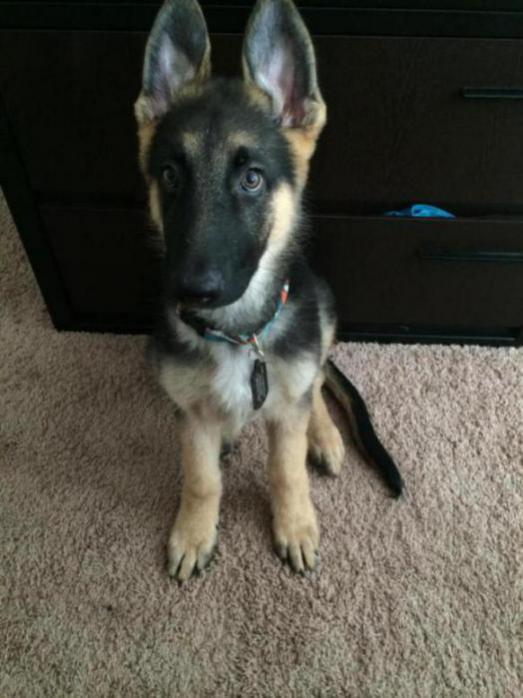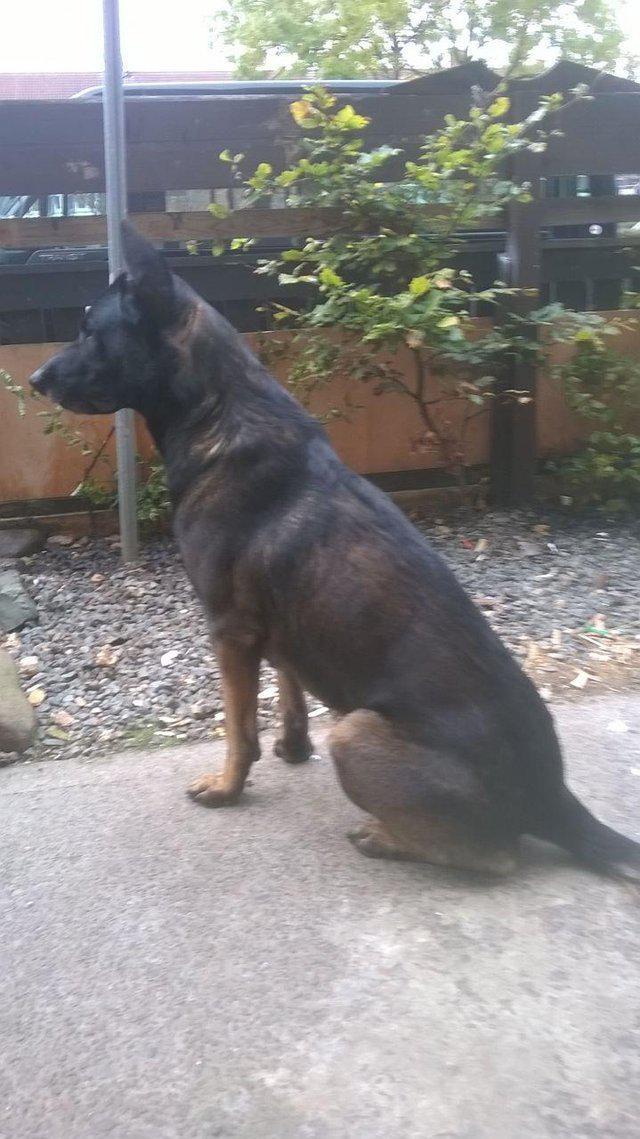The first image is the image on the left, the second image is the image on the right. Examine the images to the left and right. Is the description "A dog is standing on all fours on a hard surface and wears a leash." accurate? Answer yes or no. No. The first image is the image on the left, the second image is the image on the right. Examine the images to the left and right. Is the description "The dog in the image on the left is wearing a leash." accurate? Answer yes or no. No. 